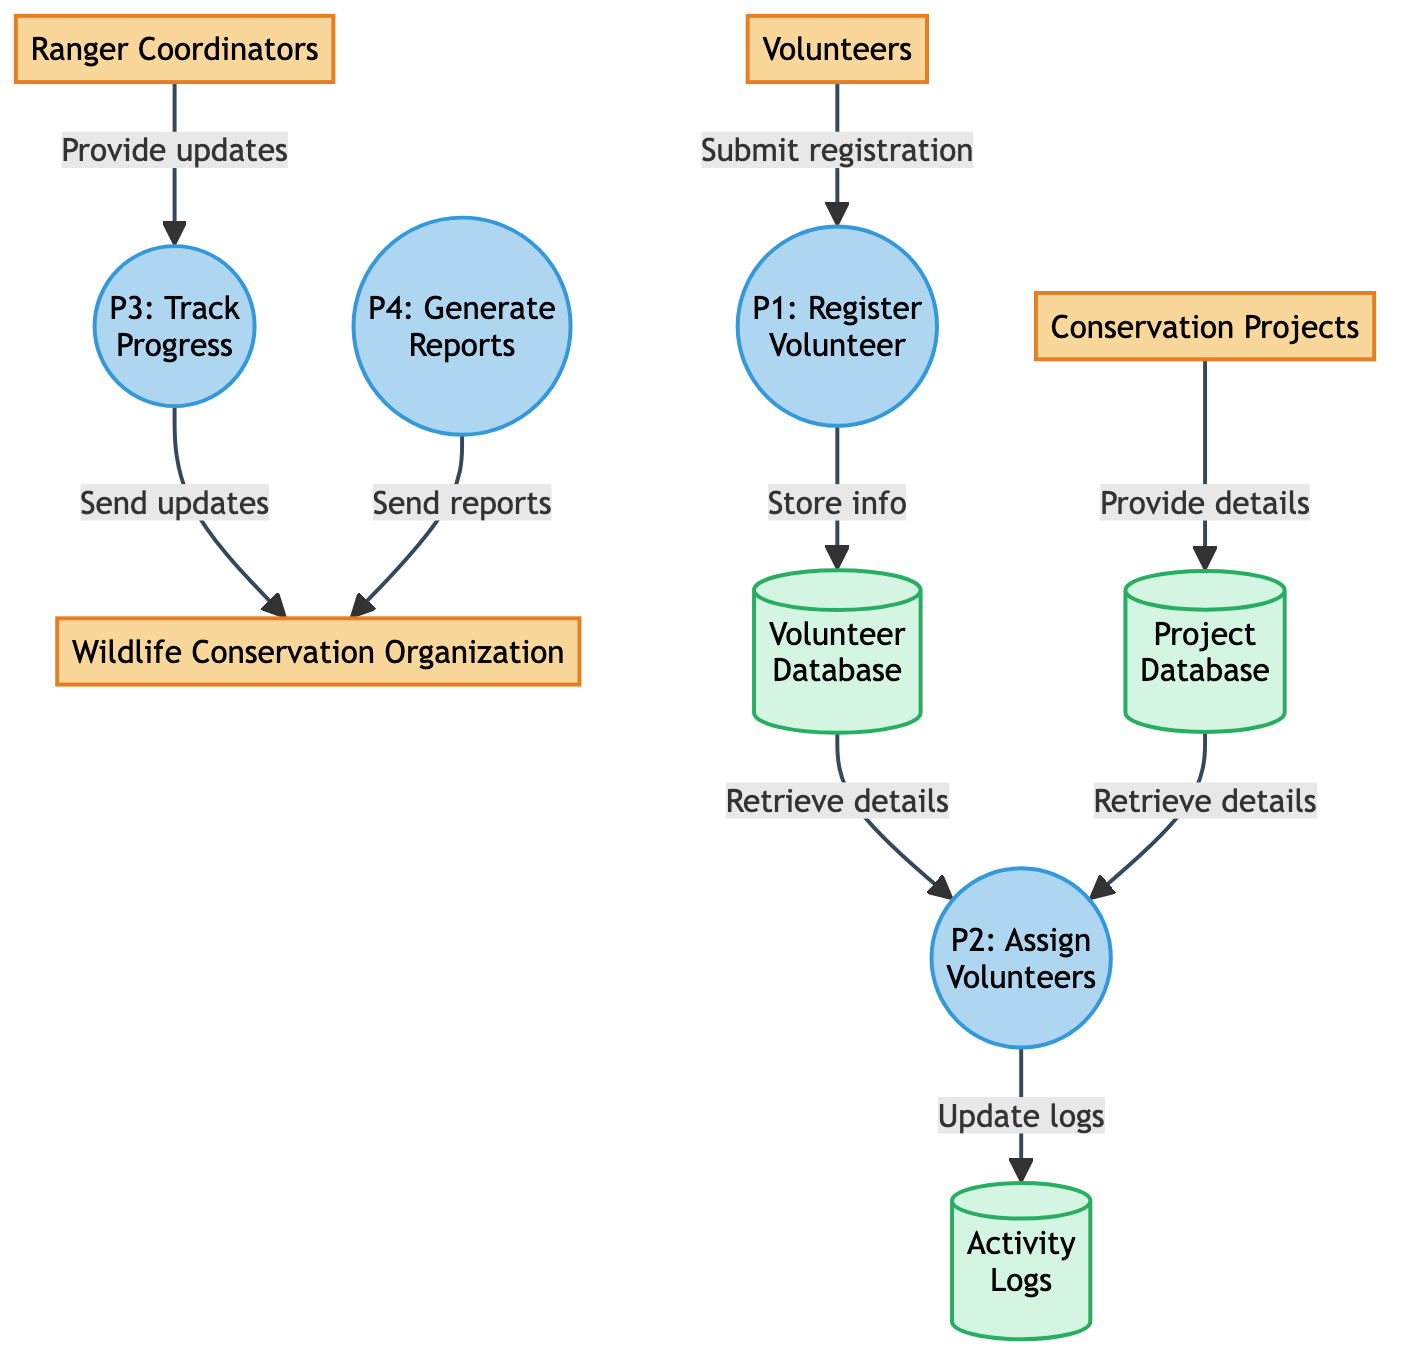What's the ID of the process that registers volunteers? The process that registers volunteers is labeled as P1, which is indicated clearly in the diagram.
Answer: P1 How many external entities are present in the diagram? By counting the entities listed in the diagram's section, there are four distinct external entities: Volunteers, Conservation Projects, Wildlife Conservation Organization, and Ranger Coordinators.
Answer: 4 What data store is used to keep activity logs? The data store dedicated to keeping activity logs is labeled as DS3, as stated in the diagram.
Answer: DS3 Which process updates the activity logs with volunteer assignments? The process responsible for updating the activity logs is P2, which assigns volunteers to projects and subsequently updates the relevant logs.
Answer: P2 What is the output of the process that tracks project progress? The output of the process P3 is project progress updates sent to the Wildlife Conservation Organization. This is indicated in the flow from P3 to the organization.
Answer: Send project progress updates Which external entity provides on-ground updates for tracking progress? The entity providing on-ground updates is the Ranger Coordinators, as shown directing their updates to the tracking progress process P3.
Answer: Ranger Coordinators How does volunteer information flow from the registration process to the volunteer database? The flow is initiated when Volunteers submit registration details to P1, and P1 then stores this information in the Volunteer Database (DS1). This sequential process demonstrates the data flow.
Answer: Store registered volunteer information What does the process that generates reports send to the Wildlife Conservation Organization? The report generation process P4 sends generated reports to the Wildlife Conservation Organization, which is clearly outlined in the diagram.
Answer: Send generated reports 